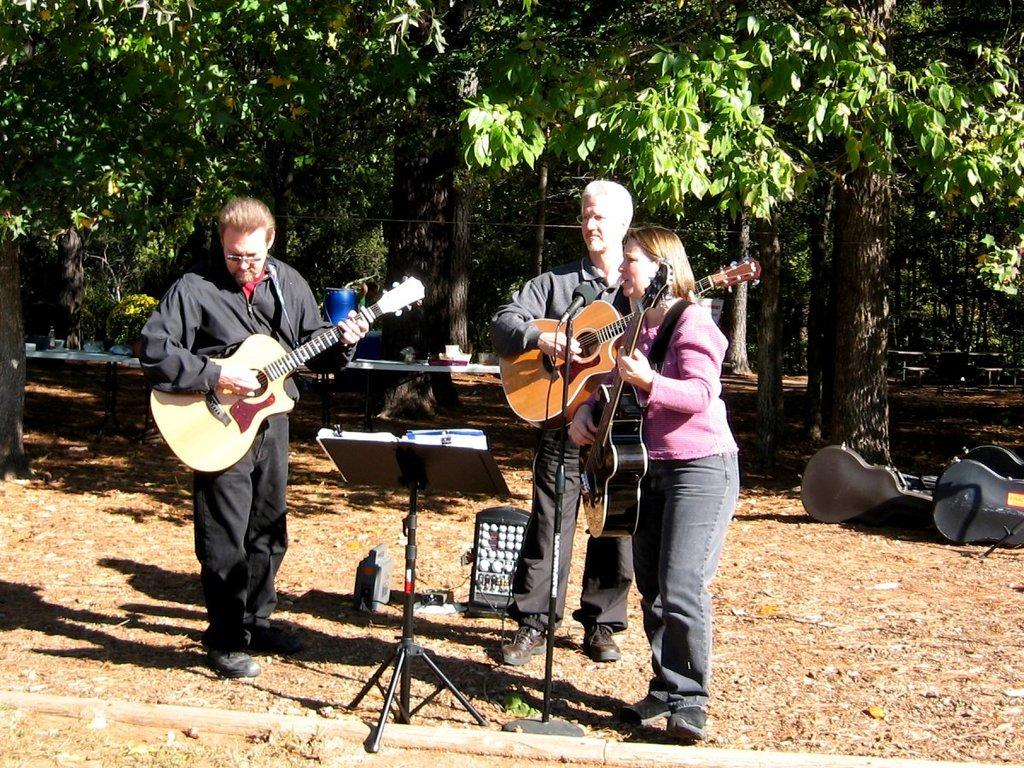Who or what can be seen in the image? There are people in the image. What are the people doing in the image? The people are standing in the image. What objects are the people holding in their hands? The people are holding guitars in their hands. What can be seen in the distance behind the people? There are trees visible in the background of the image. Where is the doll positioned in the image? There is no doll present in the image. 